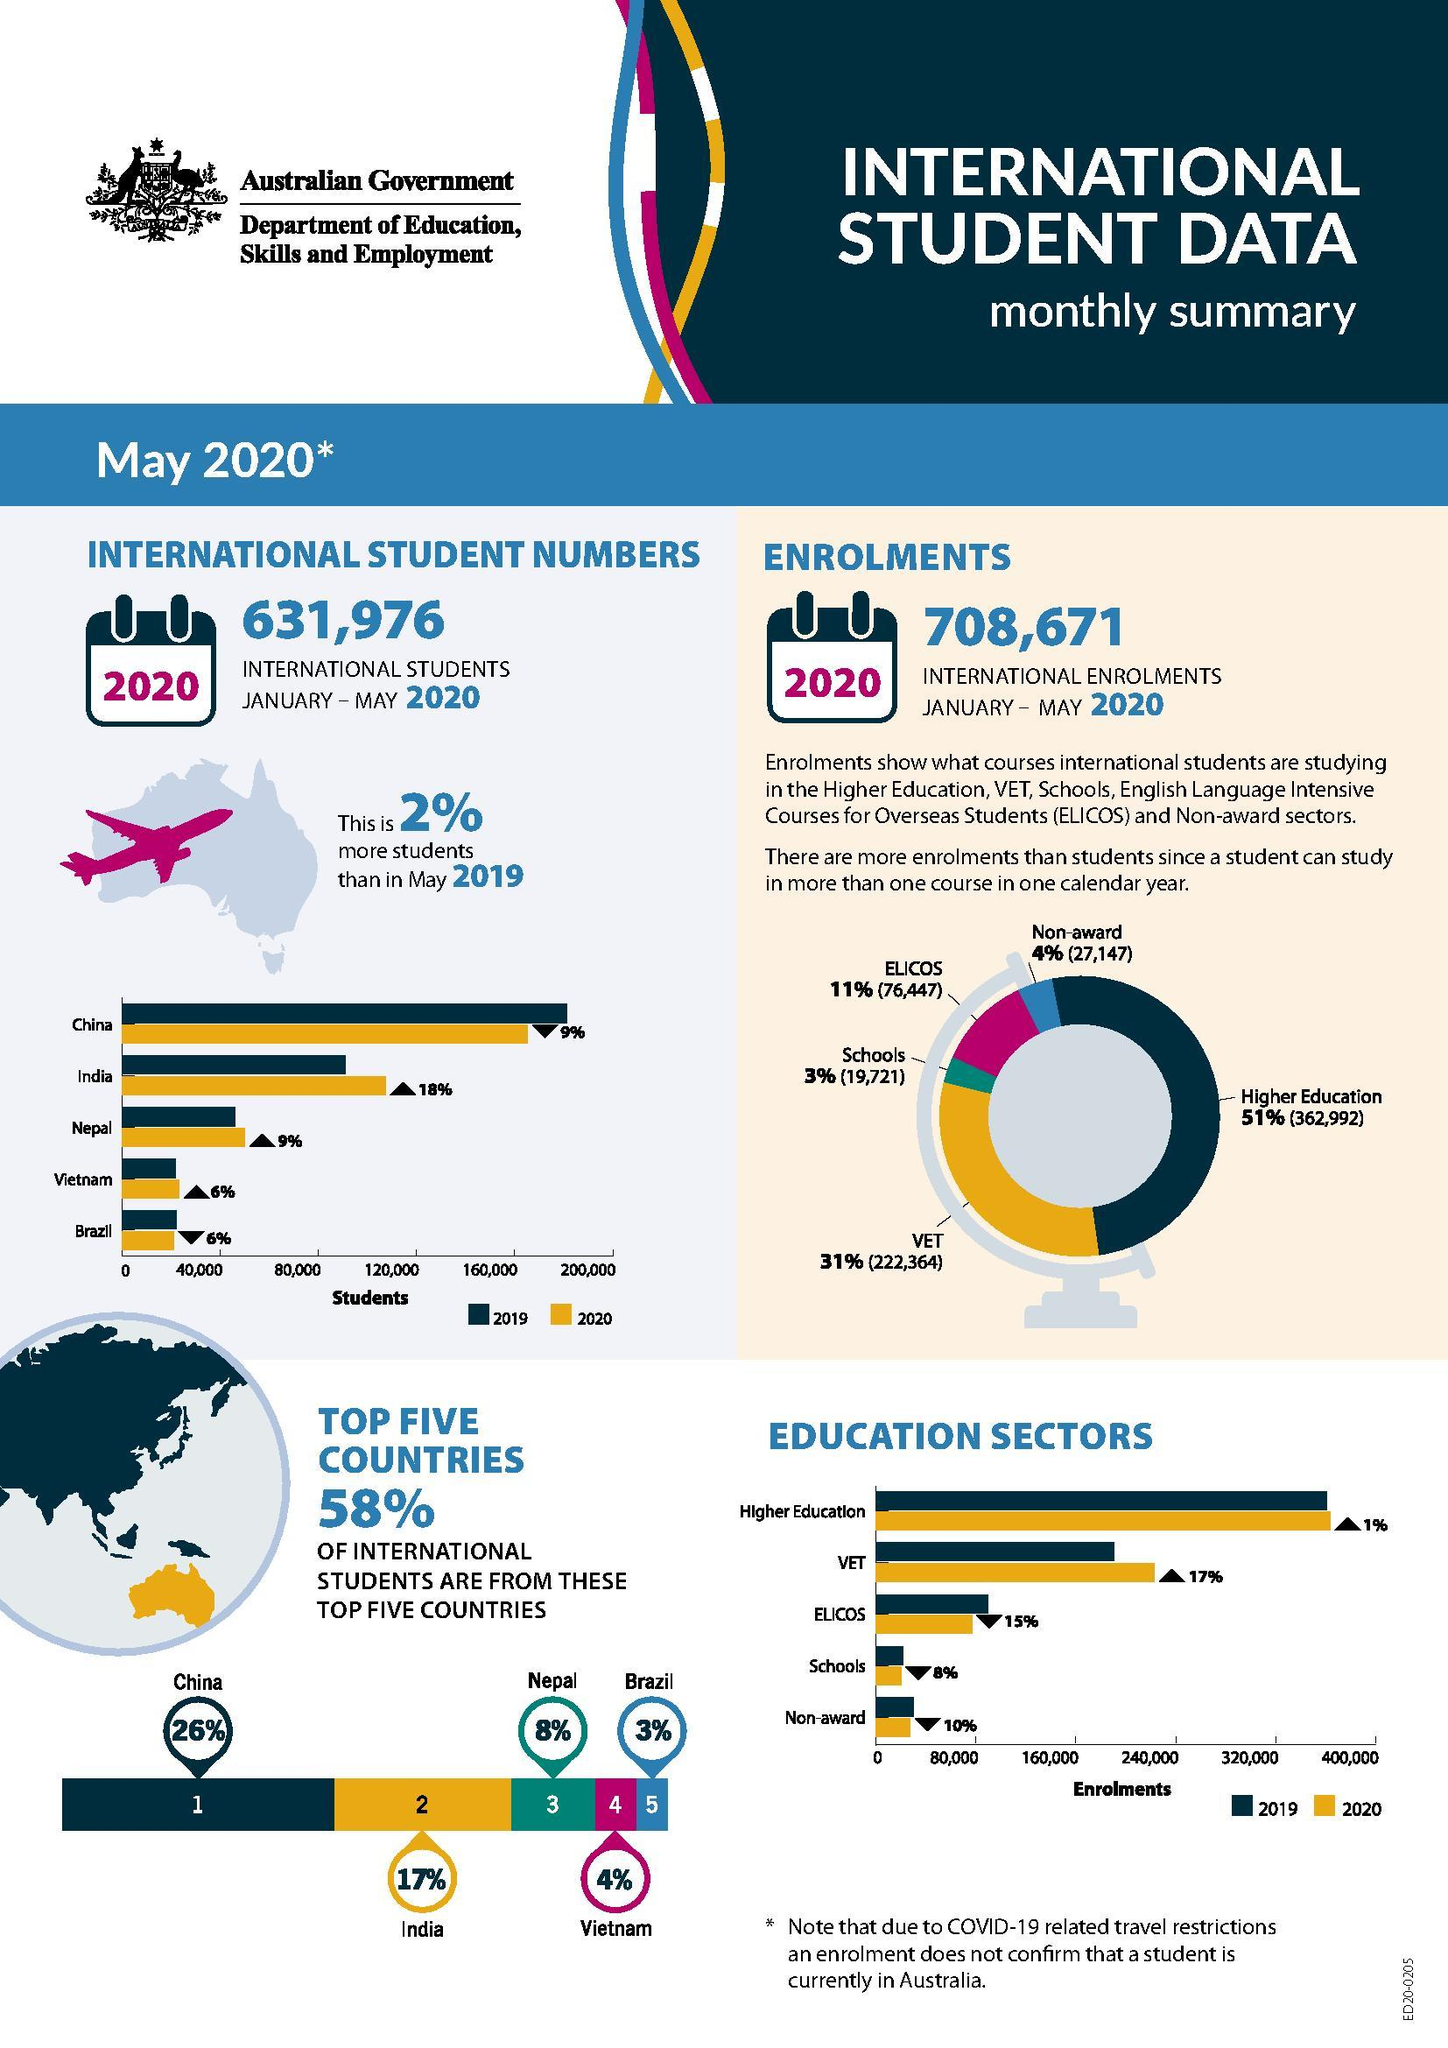Which course has highest no of students after "VET"?
Answer the question with a short phrase. ELICOS How many education sectors have enrolments greater than 160,000? 2 From which foreign country Australia has second highest number of students? India From which country there was a 6% decrease in the number of students from previous year? Brazil Which Education sector has the third largest no of students enrolled? ELICOS Which education sector has the second largest no of enrolments in 2019? VET How many education sectors have enrolments greater than 320,000? 1 From which foreign country fourth largest no of students came to Australia? Vietnam How many International enrolments happened in Australia in the year 2020? 708,671 How much is the no of enrolments more than the no of students? 76,695 